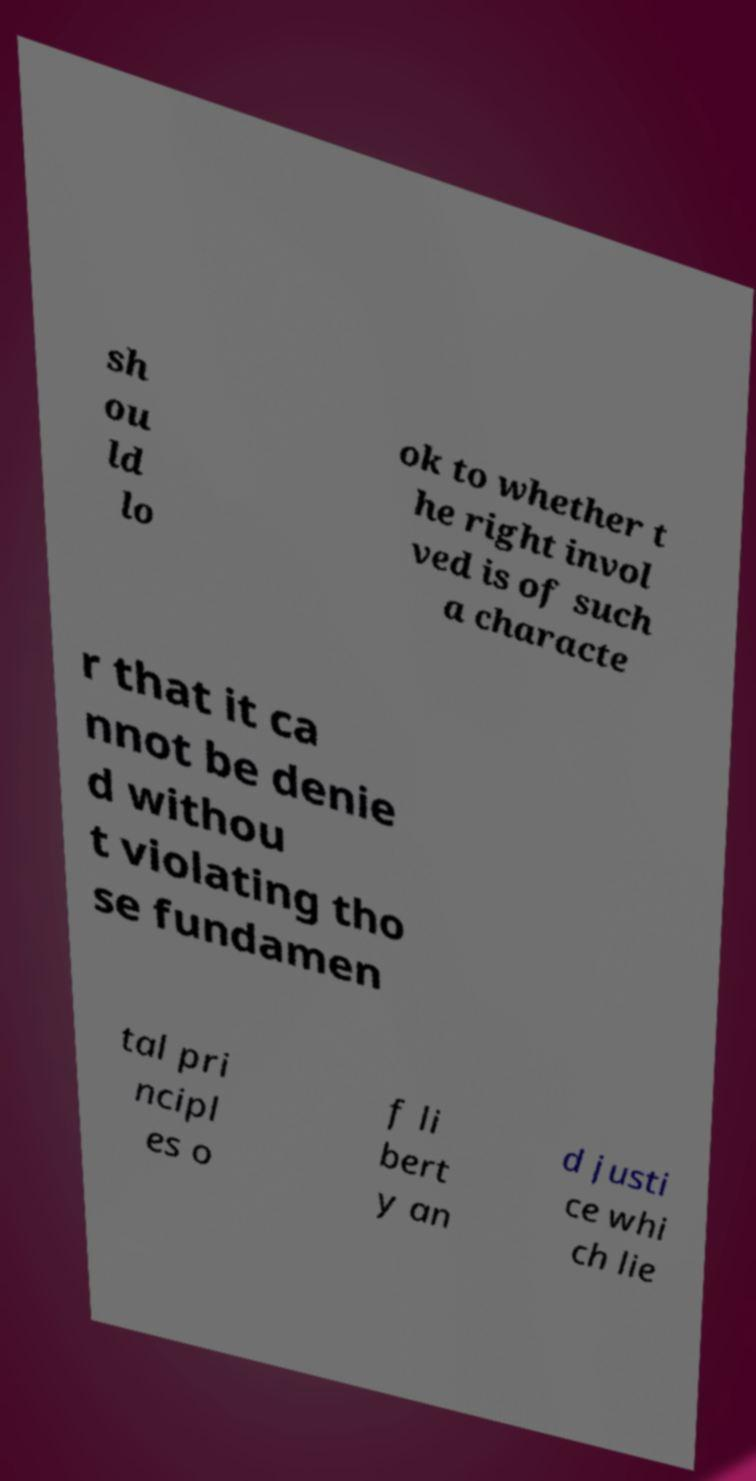For documentation purposes, I need the text within this image transcribed. Could you provide that? sh ou ld lo ok to whether t he right invol ved is of such a characte r that it ca nnot be denie d withou t violating tho se fundamen tal pri ncipl es o f li bert y an d justi ce whi ch lie 